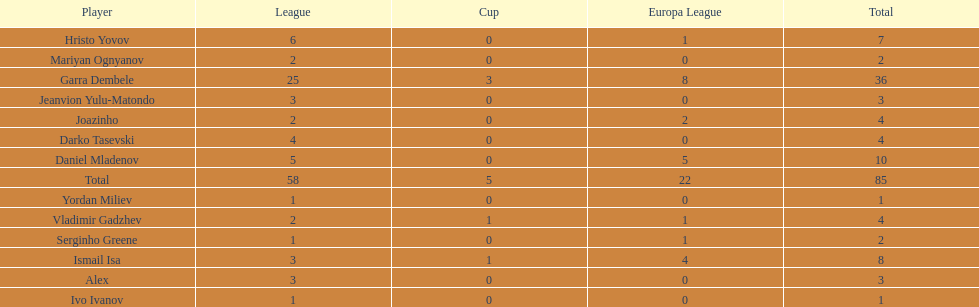What is the difference between vladimir gadzhev and yordan miliev's scores? 3. 